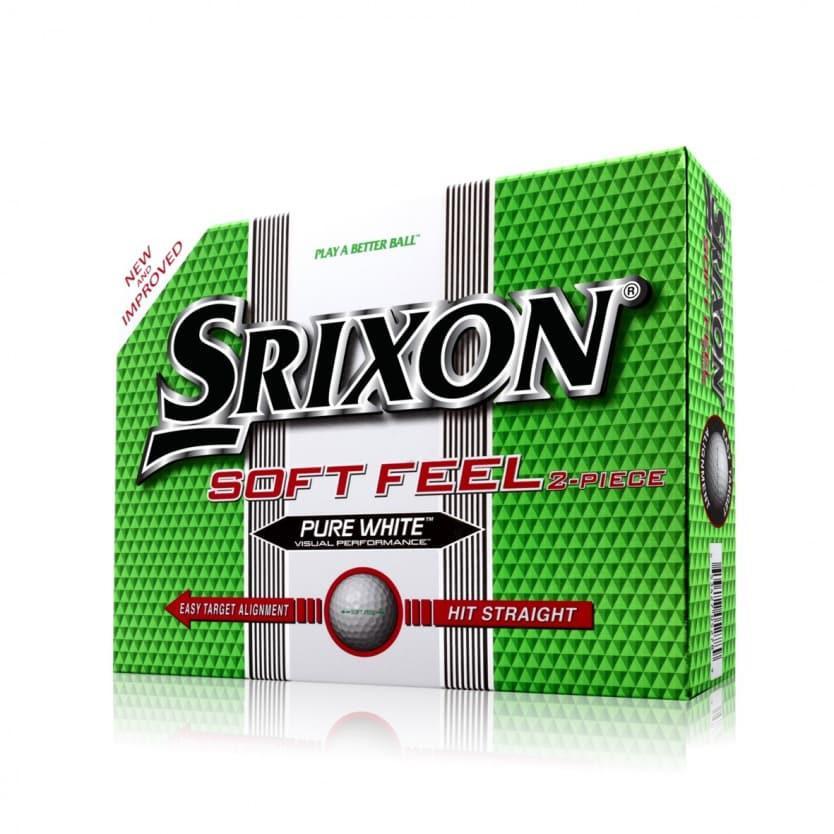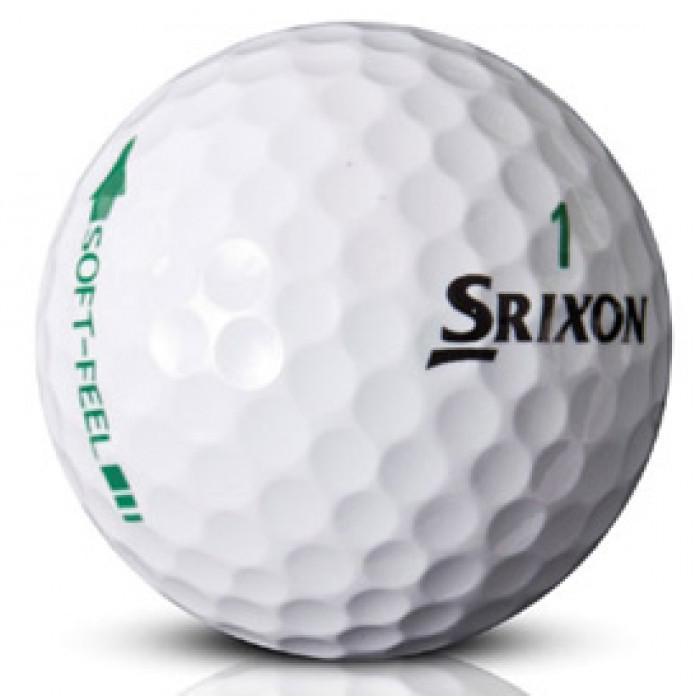The first image is the image on the left, the second image is the image on the right. For the images displayed, is the sentence "The object in the image on the left is mostly green." factually correct? Answer yes or no. Yes. 